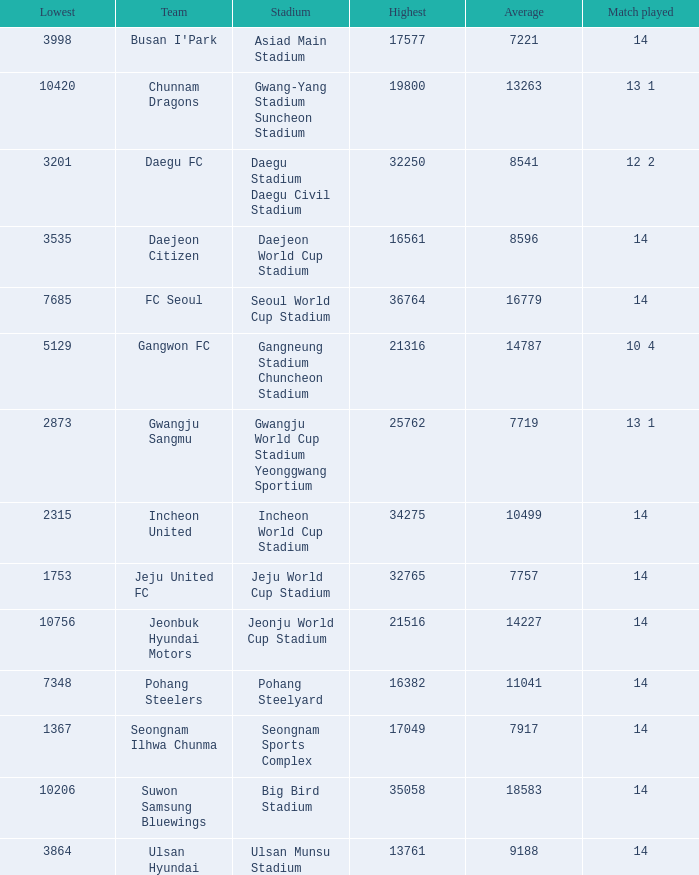Would you be able to parse every entry in this table? {'header': ['Lowest', 'Team', 'Stadium', 'Highest', 'Average', 'Match played'], 'rows': [['3998', "Busan I'Park", 'Asiad Main Stadium', '17577', '7221', '14'], ['10420', 'Chunnam Dragons', 'Gwang-Yang Stadium Suncheon Stadium', '19800', '13263', '13 1'], ['3201', 'Daegu FC', 'Daegu Stadium Daegu Civil Stadium', '32250', '8541', '12 2'], ['3535', 'Daejeon Citizen', 'Daejeon World Cup Stadium', '16561', '8596', '14'], ['7685', 'FC Seoul', 'Seoul World Cup Stadium', '36764', '16779', '14'], ['5129', 'Gangwon FC', 'Gangneung Stadium Chuncheon Stadium', '21316', '14787', '10 4'], ['2873', 'Gwangju Sangmu', 'Gwangju World Cup Stadium Yeonggwang Sportium', '25762', '7719', '13 1'], ['2315', 'Incheon United', 'Incheon World Cup Stadium', '34275', '10499', '14'], ['1753', 'Jeju United FC', 'Jeju World Cup Stadium', '32765', '7757', '14'], ['10756', 'Jeonbuk Hyundai Motors', 'Jeonju World Cup Stadium', '21516', '14227', '14'], ['7348', 'Pohang Steelers', 'Pohang Steelyard', '16382', '11041', '14'], ['1367', 'Seongnam Ilhwa Chunma', 'Seongnam Sports Complex', '17049', '7917', '14'], ['10206', 'Suwon Samsung Bluewings', 'Big Bird Stadium', '35058', '18583', '14'], ['3864', 'Ulsan Hyundai', 'Ulsan Munsu Stadium', '13761', '9188', '14']]} What is the highest when pohang steelers is the team? 16382.0. 